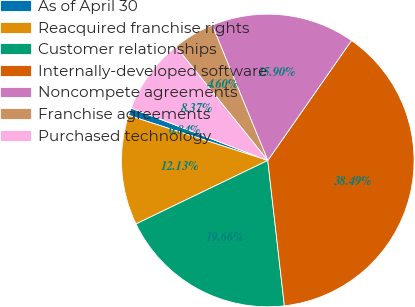Convert chart. <chart><loc_0><loc_0><loc_500><loc_500><pie_chart><fcel>As of April 30<fcel>Reacquired franchise rights<fcel>Customer relationships<fcel>Internally-developed software<fcel>Noncompete agreements<fcel>Franchise agreements<fcel>Purchased technology<nl><fcel>0.84%<fcel>12.13%<fcel>19.66%<fcel>38.49%<fcel>15.9%<fcel>4.6%<fcel>8.37%<nl></chart> 